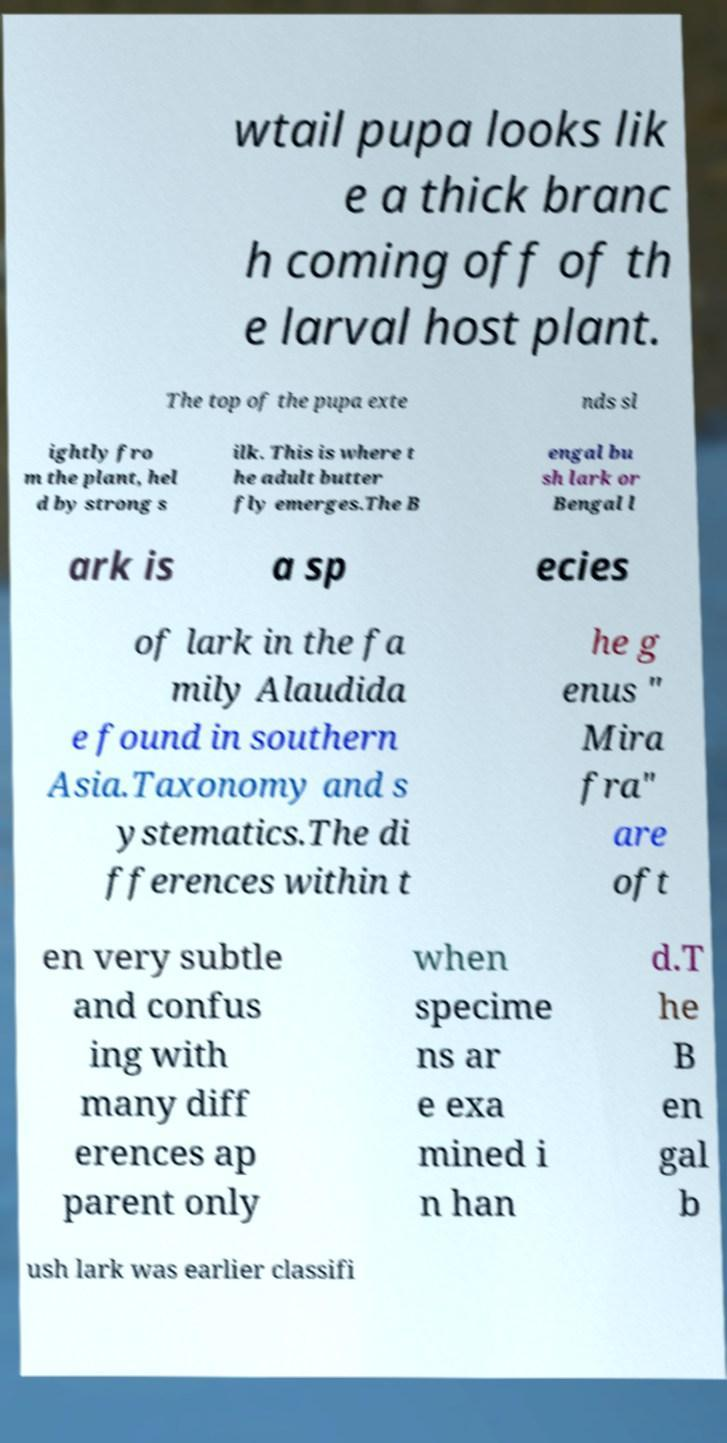Could you extract and type out the text from this image? wtail pupa looks lik e a thick branc h coming off of th e larval host plant. The top of the pupa exte nds sl ightly fro m the plant, hel d by strong s ilk. This is where t he adult butter fly emerges.The B engal bu sh lark or Bengal l ark is a sp ecies of lark in the fa mily Alaudida e found in southern Asia.Taxonomy and s ystematics.The di fferences within t he g enus " Mira fra" are oft en very subtle and confus ing with many diff erences ap parent only when specime ns ar e exa mined i n han d.T he B en gal b ush lark was earlier classifi 